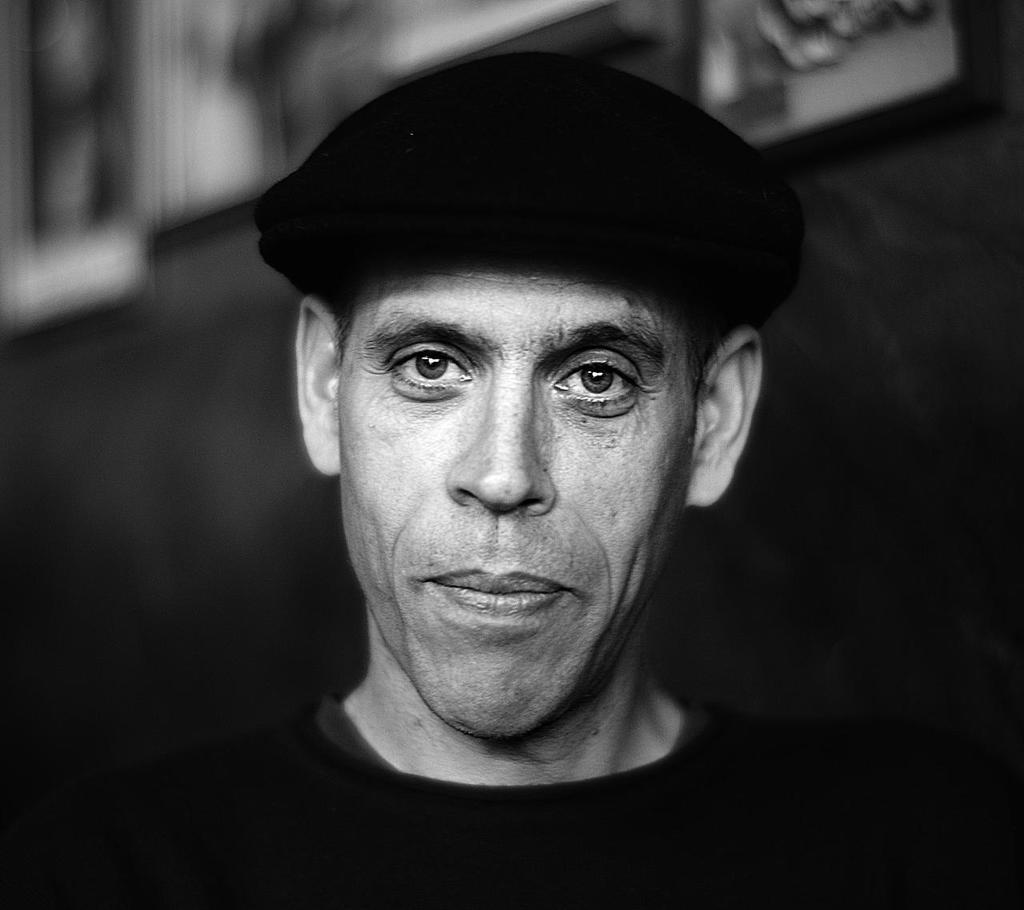How would you summarize this image in a sentence or two? This is the picture of a person face who has a black hat. 